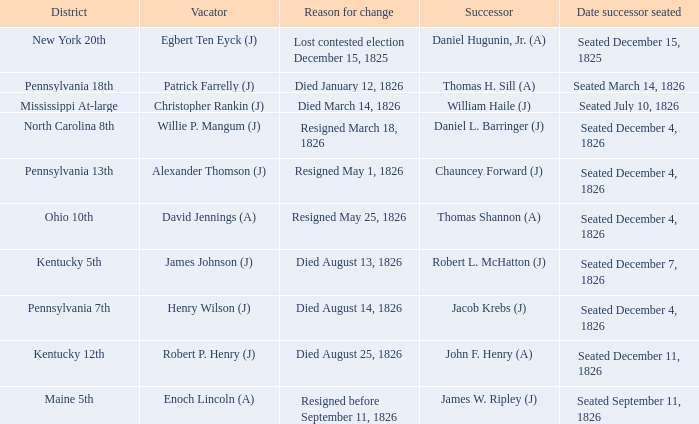Identify the person who passed away on august 13, 182 James Johnson (J). 